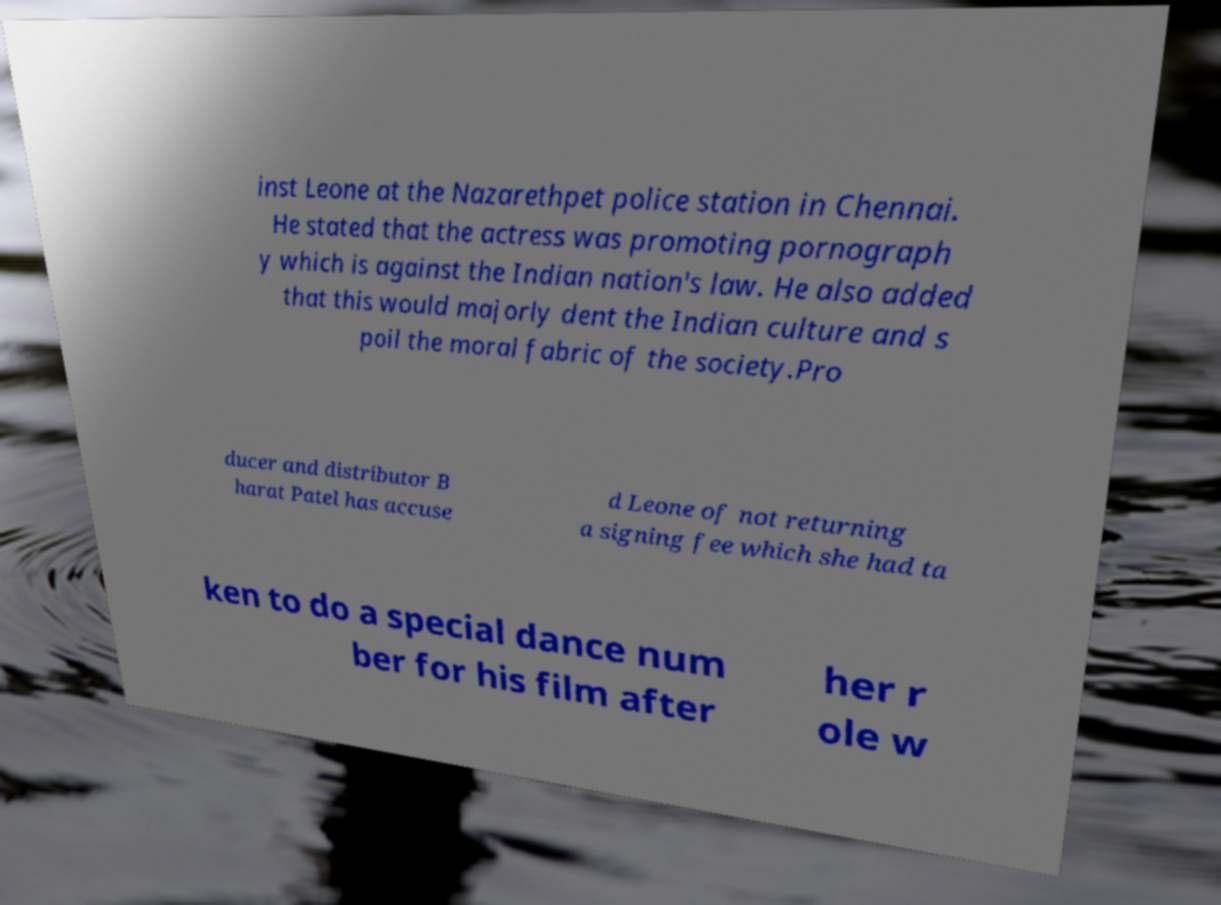For documentation purposes, I need the text within this image transcribed. Could you provide that? inst Leone at the Nazarethpet police station in Chennai. He stated that the actress was promoting pornograph y which is against the Indian nation's law. He also added that this would majorly dent the Indian culture and s poil the moral fabric of the society.Pro ducer and distributor B harat Patel has accuse d Leone of not returning a signing fee which she had ta ken to do a special dance num ber for his film after her r ole w 